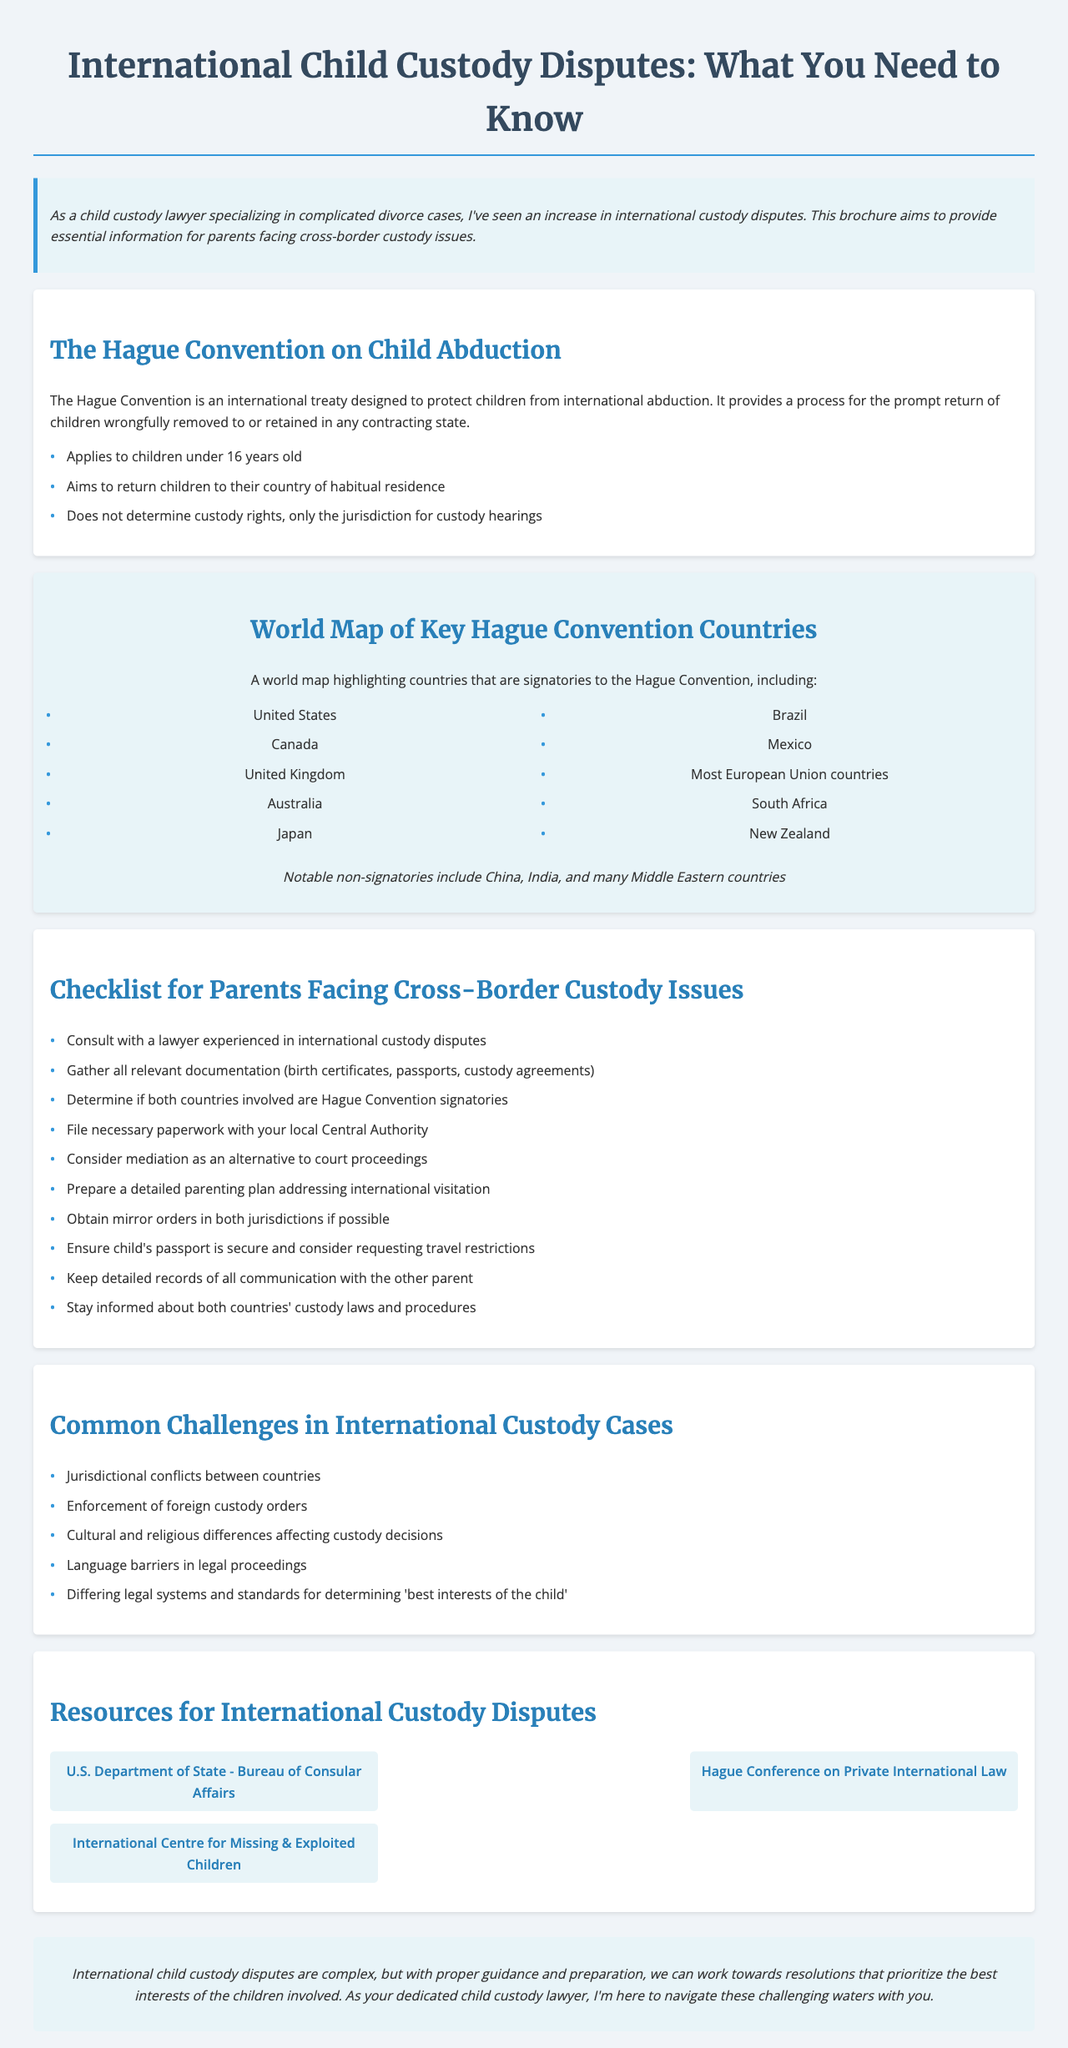What is the title of the brochure? The title is presented at the top of the document as the main heading.
Answer: International Child Custody Disputes: What You Need to Know What does the Hague Convention aim to do? The content specifies the purpose of the Hague Convention concerning child abduction and its intended outcomes.
Answer: Protect children from international abduction Which country is NOT a signatory to the Hague Convention? The document lists notable non-signatories, indicating specific countries.
Answer: China How many key points are outlined regarding the Hague Convention? The document lists key points regarding the Hague Convention, indicating a specific number of them mentioned.
Answer: Three What is one item on the checklist for parents? The checklist includes multiple items; one example can be directly extracted from it.
Answer: Consult with a lawyer experienced in international custody disputes What common challenge involves legal systems? The challenges discussed in the document include various topics related to international custody cases.
Answer: Differing legal systems and standards for determining 'best interests of the child' Name one resource provided for international custody disputes. The document lists several resources with specific names and websites.
Answer: U.S. Department of State - Bureau of Consular Affairs Which country's passport should be secured according to the checklist? The checklist directly mentions the importance of securing a specific type of document.
Answer: Child's passport What type of legal proceedings does the document suggest as an alternative? The checklist indicates various possible approaches parents could consider, suggesting one.
Answer: Mediation 